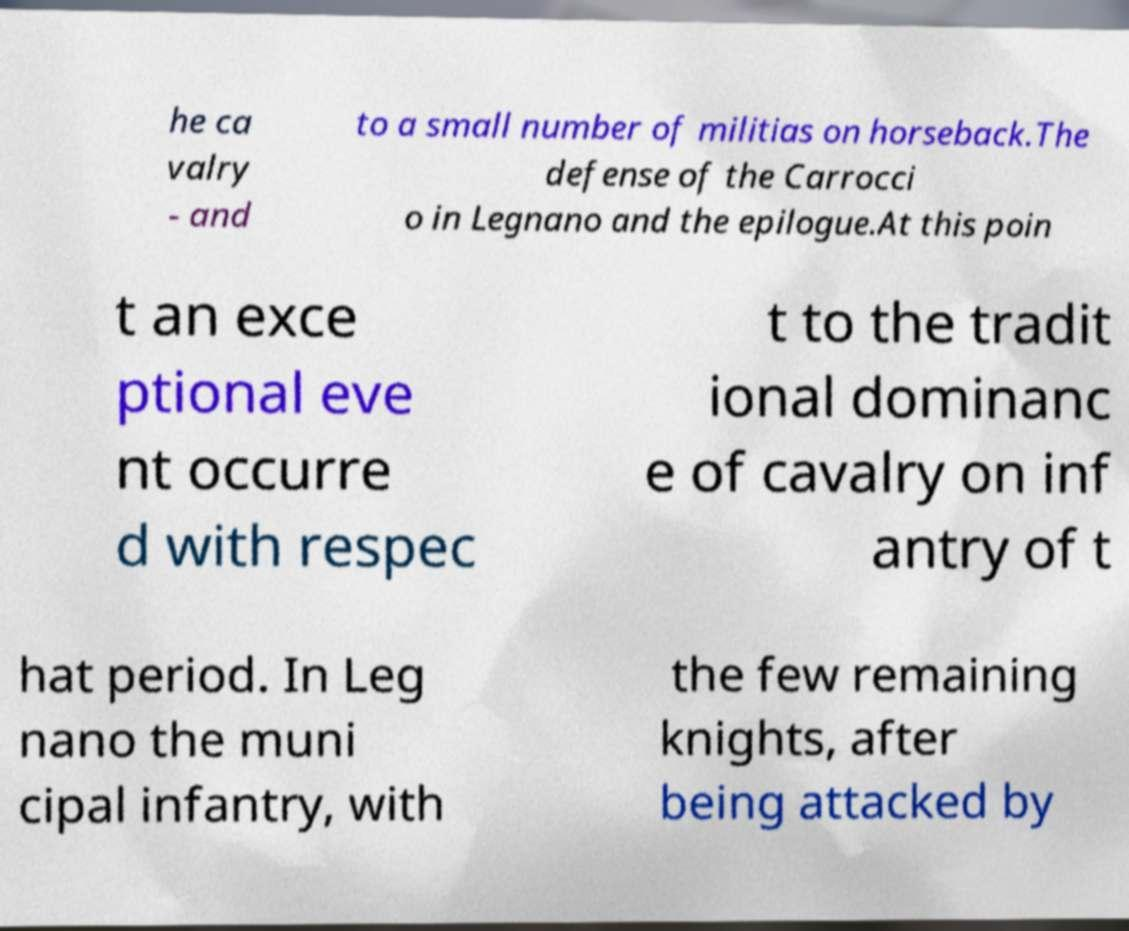What messages or text are displayed in this image? I need them in a readable, typed format. he ca valry - and to a small number of militias on horseback.The defense of the Carrocci o in Legnano and the epilogue.At this poin t an exce ptional eve nt occurre d with respec t to the tradit ional dominanc e of cavalry on inf antry of t hat period. In Leg nano the muni cipal infantry, with the few remaining knights, after being attacked by 